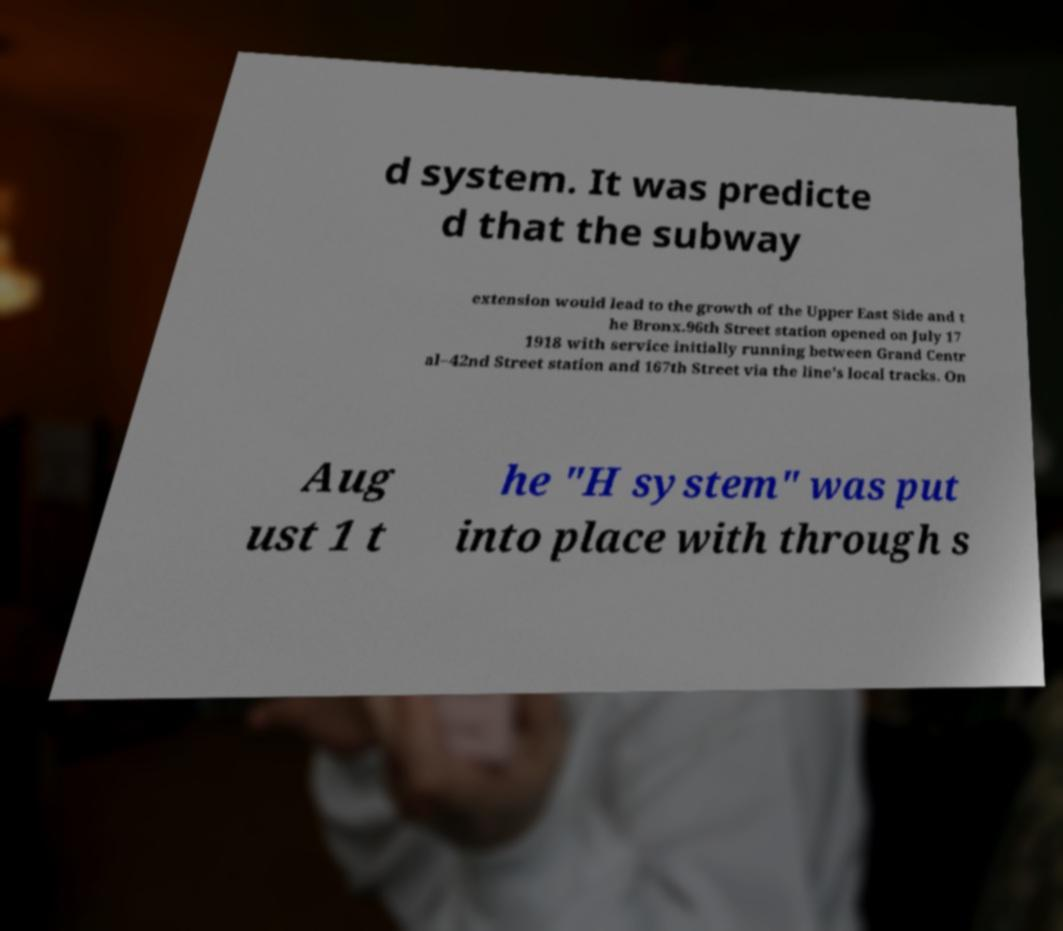Can you read and provide the text displayed in the image?This photo seems to have some interesting text. Can you extract and type it out for me? d system. It was predicte d that the subway extension would lead to the growth of the Upper East Side and t he Bronx.96th Street station opened on July 17 1918 with service initially running between Grand Centr al–42nd Street station and 167th Street via the line's local tracks. On Aug ust 1 t he "H system" was put into place with through s 